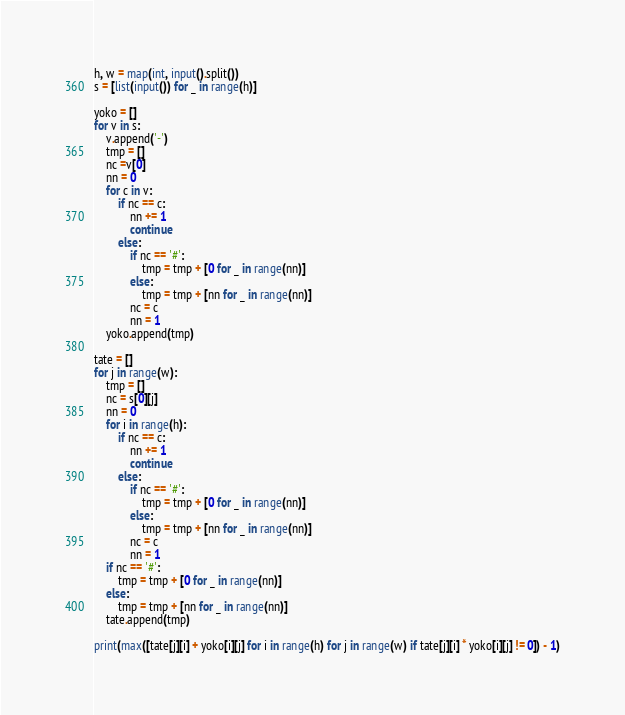Convert code to text. <code><loc_0><loc_0><loc_500><loc_500><_Python_>h, w = map(int, input().split())
s = [list(input()) for _ in range(h)]

yoko = []
for v in s:
    v.append('-')
    tmp = []
    nc =v[0]
    nn = 0
    for c in v:
        if nc == c:
            nn += 1
            continue
        else:
            if nc == '#':
                tmp = tmp + [0 for _ in range(nn)]
            else:
                tmp = tmp + [nn for _ in range(nn)]
            nc = c
            nn = 1
    yoko.append(tmp)

tate = []
for j in range(w):
    tmp = []
    nc = s[0][j]
    nn = 0
    for i in range(h):
        if nc == c:
            nn += 1
            continue
        else:
            if nc == '#':
                tmp = tmp + [0 for _ in range(nn)]
            else:
                tmp = tmp + [nn for _ in range(nn)]
            nc = c
            nn = 1
    if nc == '#':
        tmp = tmp + [0 for _ in range(nn)]
    else:
        tmp = tmp + [nn for _ in range(nn)]
    tate.append(tmp)

print(max([tate[j][i] + yoko[i][j] for i in range(h) for j in range(w) if tate[j][i] * yoko[i][j] != 0]) - 1)
</code> 